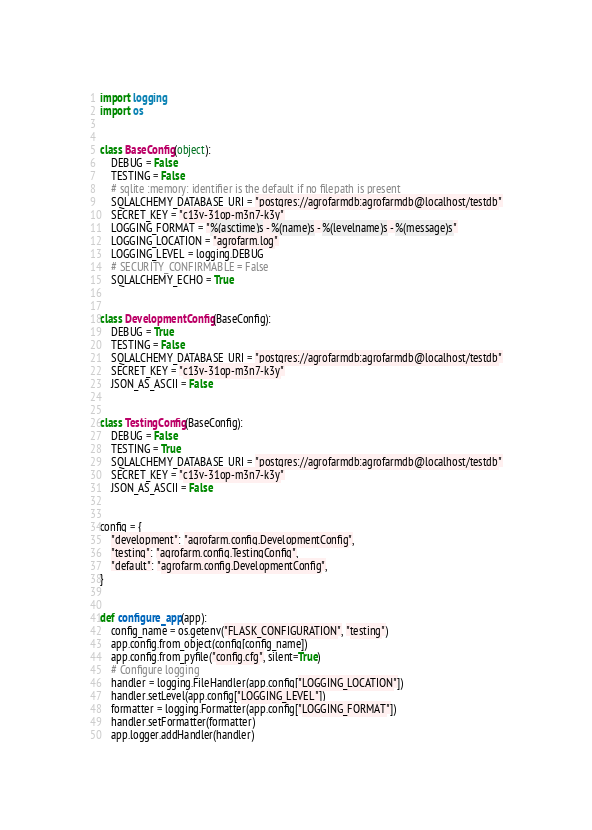Convert code to text. <code><loc_0><loc_0><loc_500><loc_500><_Python_>import logging
import os


class BaseConfig(object):
    DEBUG = False
    TESTING = False
    # sqlite :memory: identifier is the default if no filepath is present
    SQLALCHEMY_DATABASE_URI = "postgres://agrofarmdb:agrofarmdb@localhost/testdb"
    SECRET_KEY = "c13v-31op-m3n7-k3y"
    LOGGING_FORMAT = "%(asctime)s - %(name)s - %(levelname)s - %(message)s"
    LOGGING_LOCATION = "agrofarm.log"
    LOGGING_LEVEL = logging.DEBUG
    # SECURITY_CONFIRMABLE = False
    SQLALCHEMY_ECHO = True


class DevelopmentConfig(BaseConfig):
    DEBUG = True
    TESTING = False
    SQLALCHEMY_DATABASE_URI = "postgres://agrofarmdb:agrofarmdb@localhost/testdb"
    SECRET_KEY = "c13v-31op-m3n7-k3y"
    JSON_AS_ASCII = False


class TestingConfig(BaseConfig):
    DEBUG = False
    TESTING = True
    SQLALCHEMY_DATABASE_URI = "postgres://agrofarmdb:agrofarmdb@localhost/testdb"
    SECRET_KEY = "c13v-31op-m3n7-k3y"
    JSON_AS_ASCII = False


config = {
    "development": "agrofarm.config.DevelopmentConfig",
    "testing": "agrofarm.config.TestingConfig",
    "default": "agrofarm.config.DevelopmentConfig",
}


def configure_app(app):
    config_name = os.getenv("FLASK_CONFIGURATION", "testing")
    app.config.from_object(config[config_name])
    app.config.from_pyfile("config.cfg", silent=True)
    # Configure logging
    handler = logging.FileHandler(app.config["LOGGING_LOCATION"])
    handler.setLevel(app.config["LOGGING_LEVEL"])
    formatter = logging.Formatter(app.config["LOGGING_FORMAT"])
    handler.setFormatter(formatter)
    app.logger.addHandler(handler)
</code> 